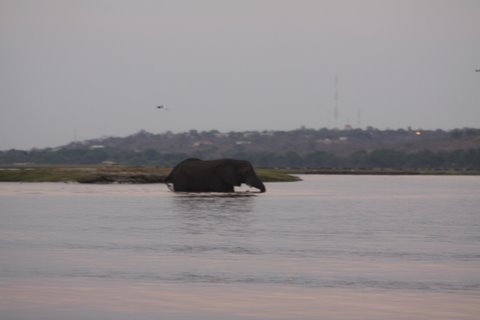Describe the objects in this image and their specific colors. I can see elephant in darkgray, black, and gray tones and bird in darkgray and gray tones in this image. 